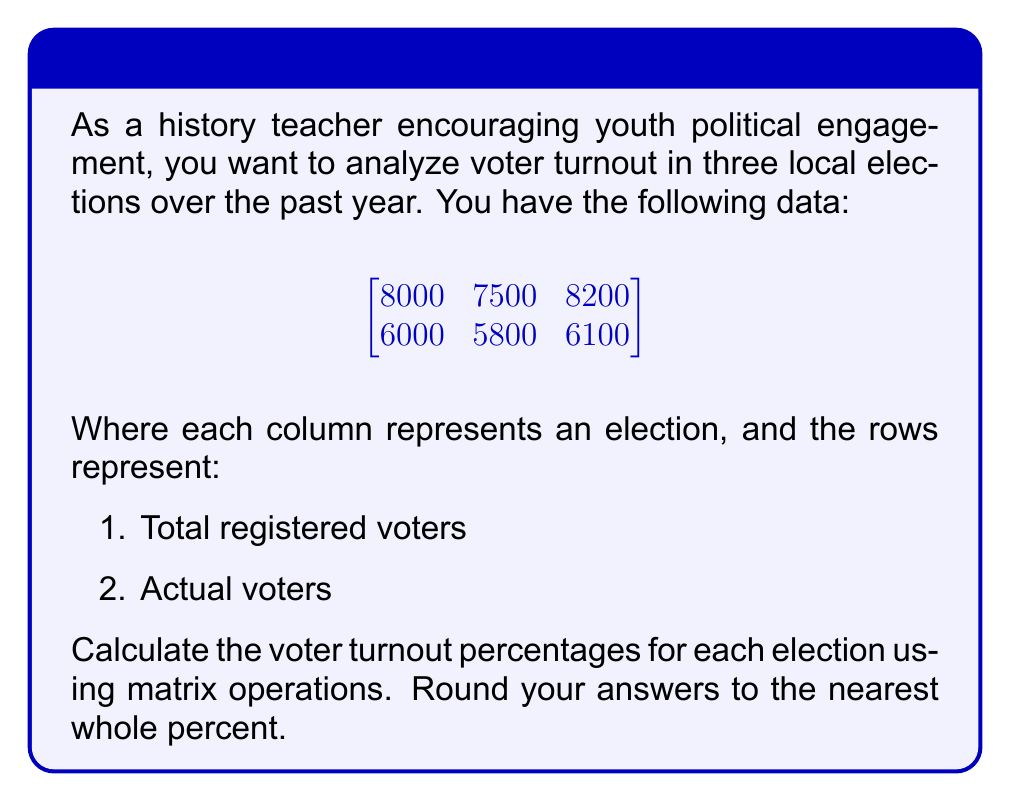What is the answer to this math problem? Let's approach this step-by-step:

1) First, we need to calculate the turnout percentages. The formula is:
   $\text{Turnout Percentage} = \frac{\text{Actual Voters}}{\text{Total Registered Voters}} \times 100\%$

2) We can represent this as a matrix operation. Let's call our original matrix A:

   $$A = \begin{bmatrix}
   8000 & 7500 & 8200 \\
   6000 & 5800 & 6100
   \end{bmatrix}$$

3) To calculate the percentages, we need to divide each element in the second row by the corresponding element in the first row. In matrix notation, this is equivalent to element-wise division of the second row by the first row.

4) We can achieve this by first taking the reciprocal of each element in the first row:

   $$B = \begin{bmatrix}
   \frac{1}{8000} & \frac{1}{7500} & \frac{1}{8200} \\
   1 & 1 & 1
   \end{bmatrix}$$

5) Then, we perform element-wise multiplication of A and B:

   $$C = A \odot B = \begin{bmatrix}
   8000 \cdot \frac{1}{8000} & 7500 \cdot \frac{1}{7500} & 8200 \cdot \frac{1}{8200} \\
   6000 \cdot 1 & 5800 \cdot 1 & 6100 \cdot 1
   \end{bmatrix}$$

6) This simplifies to:

   $$C = \begin{bmatrix}
   1 & 1 & 1 \\
   6000 & 5800 & 6100
   \end{bmatrix}$$

7) The second row of C now contains the decimal representations of the turnout percentages.

8) Multiply by 100 to get percentages and round to the nearest whole number:

   $$\text{Turnout Percentages} = \begin{bmatrix}
   75\% & 77\% & 74\%
   \end{bmatrix}$$
Answer: $\begin{bmatrix} 75\% & 77\% & 74\% \end{bmatrix}$ 